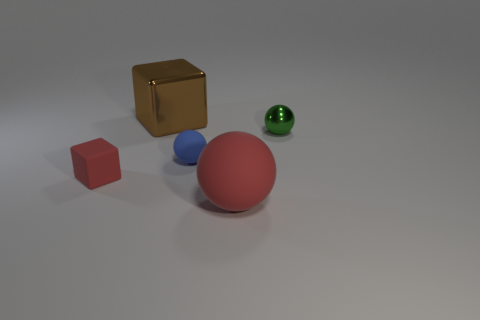How does the lighting affect the appearance of these objects? The lighting in the image casts soft shadows behind each object, suggesting a single light source from above and to the left. This illuminates the scene calmly and tends to emphasize the three-dimensionality of the objects. The lighting also affects the objects' colors by highlighting their textures and the reflective quality of the gold cube, while allowing the matte surfaces of the spheres to absorb more light, which diminishes reflective glare and showcases their colors more naturally. 